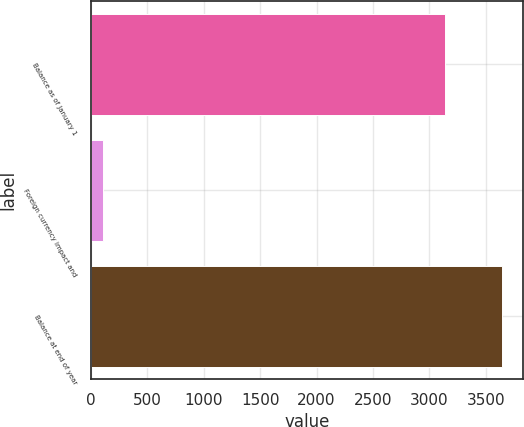<chart> <loc_0><loc_0><loc_500><loc_500><bar_chart><fcel>Balance as of January 1<fcel>Foreign currency impact and<fcel>Balance at end of year<nl><fcel>3137.7<fcel>108.8<fcel>3644.8<nl></chart> 